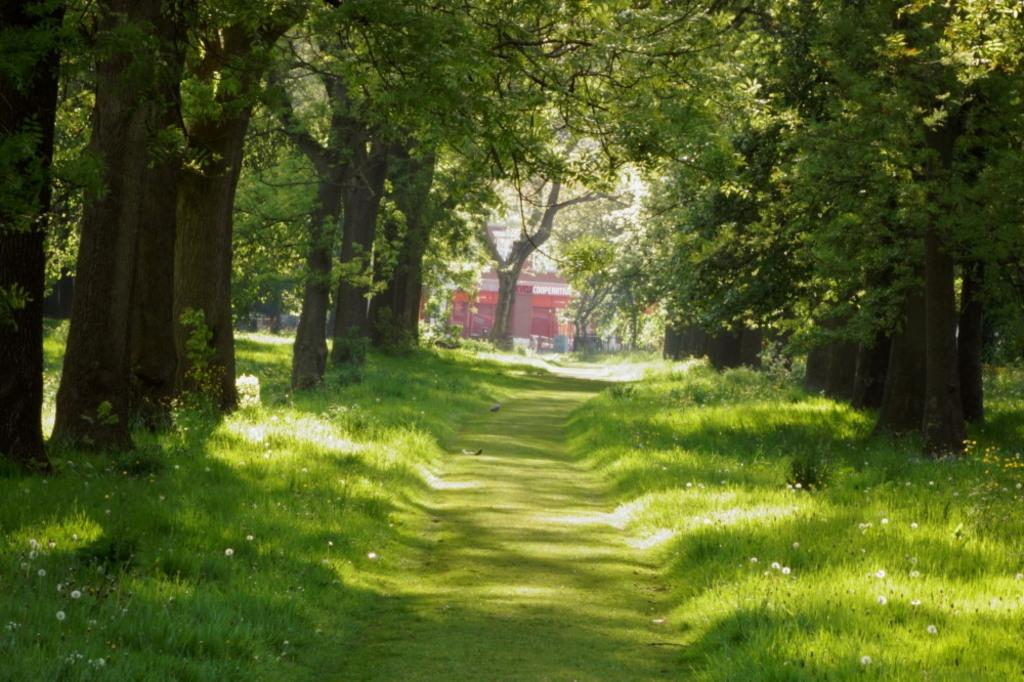What type of vegetation is present in the image? There is green grass in the image. What can be seen in the image that people might walk on? There is a walkway in the image. Where are the trees located in the image? There are trees on both the left and right sides of the image. Can you tell me how many kitties are playing on the arm in the image? There is no kitty or arm present in the image. What direction are the trees leaning in the image? The trees are not leaning in any specific direction in the image; they are standing upright. 